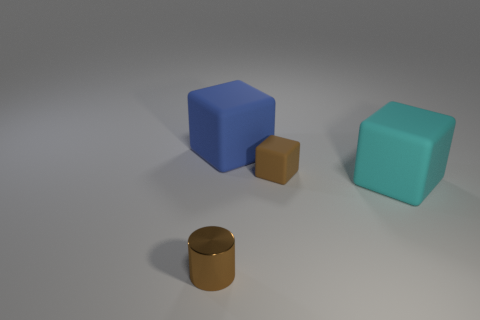How big are the cubes compared to the cylinder? The cubes are considerably larger than the cylinder. The blue and the teal cubes are about the same size, which could be estimated at roughly four to five times the height of the cylindrical object.  What do the shadows tell us about the light source? The shadows indicate that the light source is coming from the upper left side of the composition. The angle and length of the shadows suggest a single light source that is not directly overhead but spaced at an angle, creating elongated shadows to the right of the objects. 